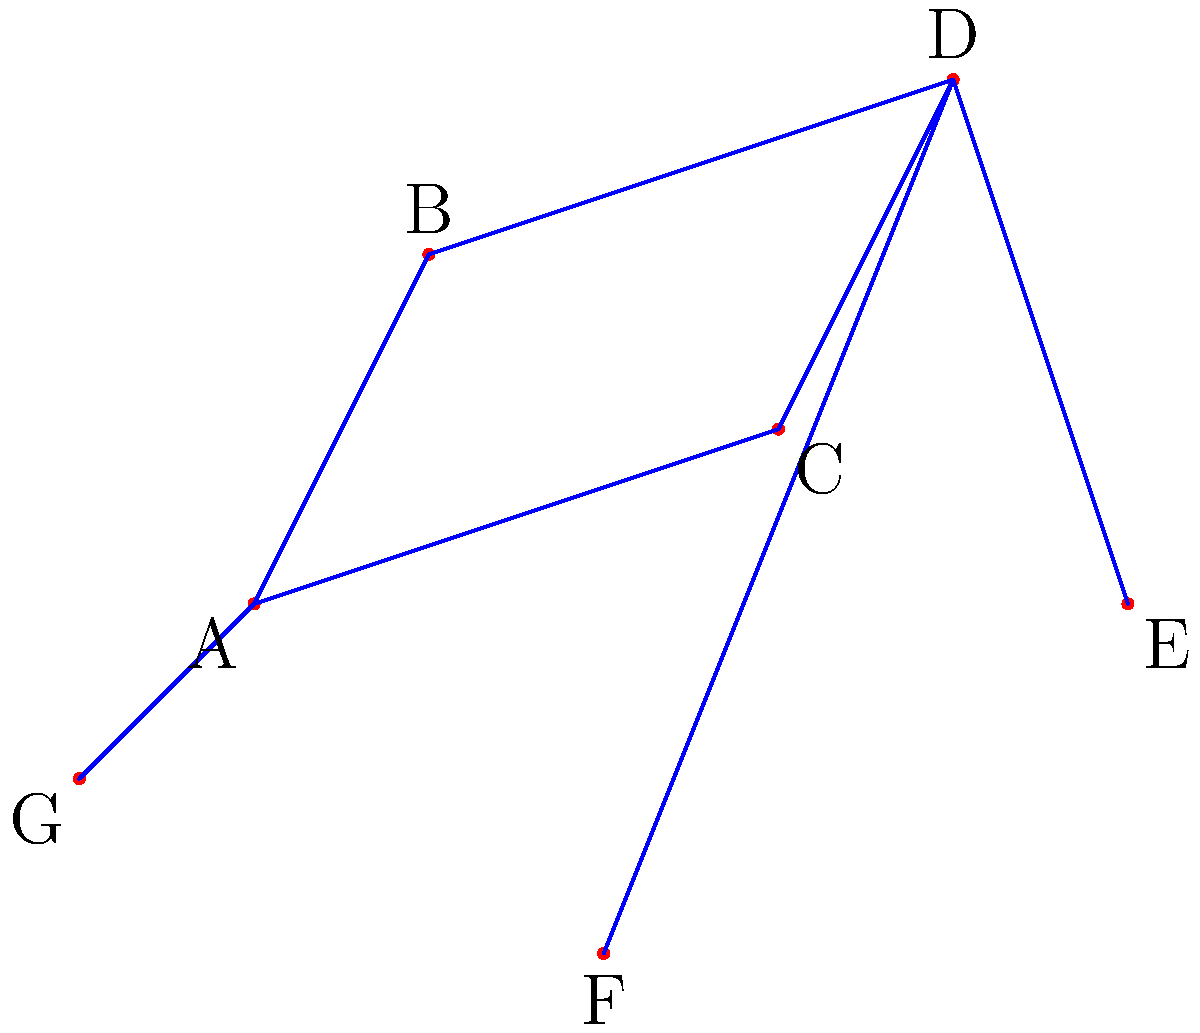As an HR manager organizing a team-building stargazing event, you're asked to identify the shape of the constellation formed by connecting stars A, B, D, and E in the simplified star chart. What common household item does this shape resemble? To identify the shape formed by stars A, B, D, and E, let's follow these steps:

1. Locate the stars A, B, D, and E on the chart.
2. Mentally connect these stars in the order A-B-D-E.
3. Analyze the resulting shape:
   - Star A is at the bottom left
   - Star B is above and slightly to the right of A
   - Star D is further up and to the right of B
   - Star E is down and to the right of D

4. The shape formed is a quadrilateral with:
   - A long bottom side (A to E)
   - Two shorter sides on the left (A to B) and right (D to E)
   - A longer top side (B to D) that slopes upward from left to right

5. This shape closely resembles a common household item used for ironing clothes.

The constellation formed by stars A, B, D, and E resembles the shape of an iron, the household appliance used for pressing clothes.
Answer: Iron 